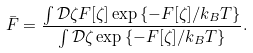<formula> <loc_0><loc_0><loc_500><loc_500>\bar { F } = \frac { \int \mathcal { D } \zeta F [ \zeta ] \exp \left \{ - F [ \zeta ] / k _ { B } T \right \} } { \int \mathcal { D } \zeta \exp \left \{ - F [ \zeta ] / k _ { B } T \right \} } .</formula> 